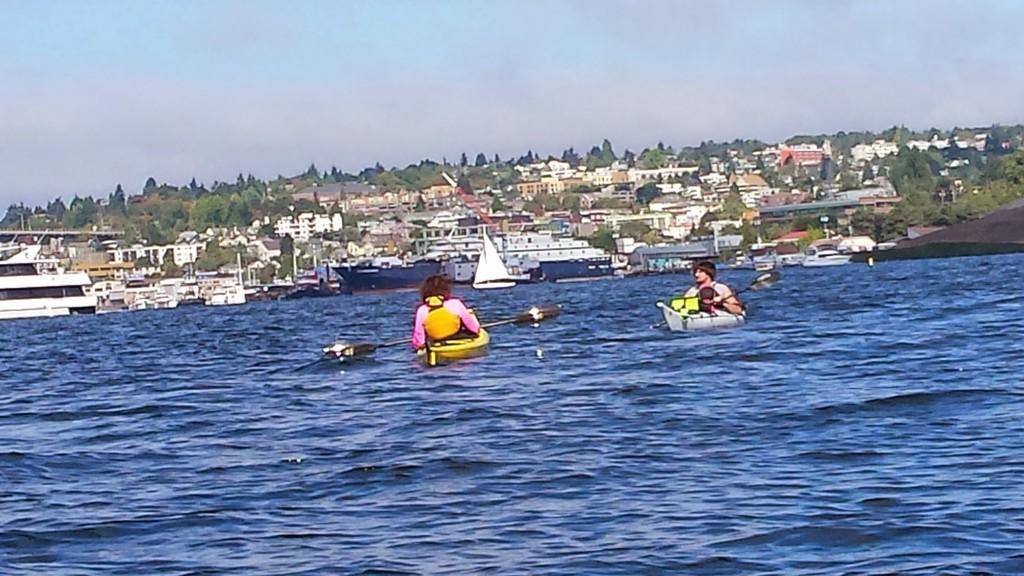How would you summarize this image in a sentence or two? In this image there are two persons floating on an individual boat, which is on the river. In the background there are buildings, trees and a sky. 